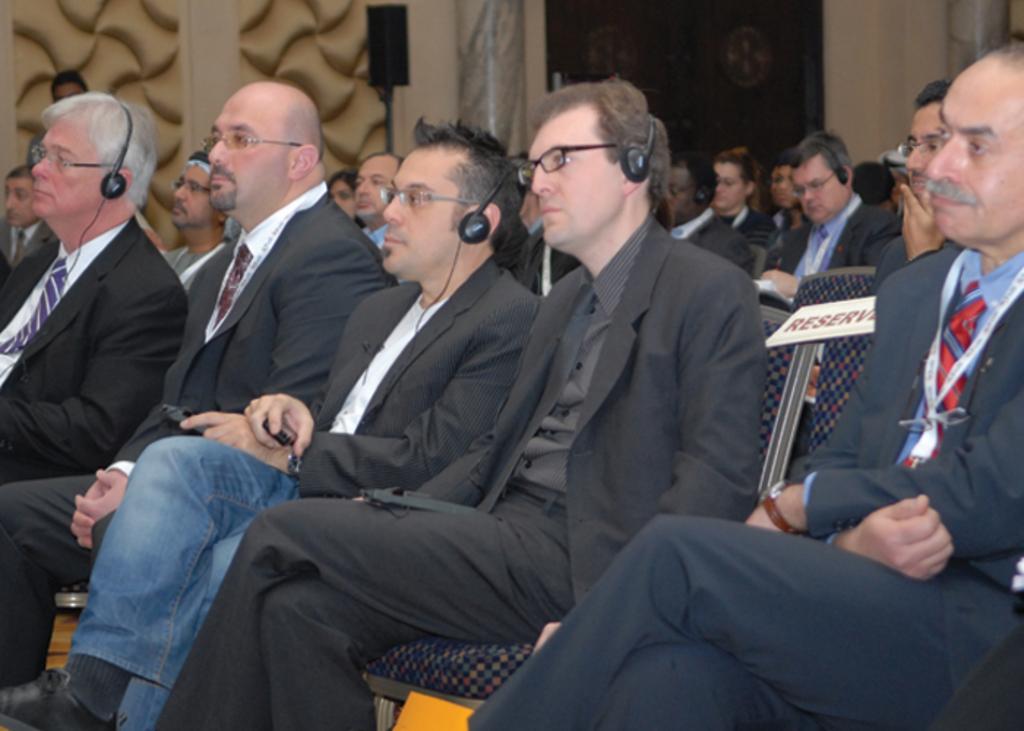Please provide a concise description of this image. In the foreground of this image, there are five men sitting on the chairs and three are wearing headsets. In the background, there are persons sitting on the chairs, a speaker box to the stand, wall, pillars and the door. 